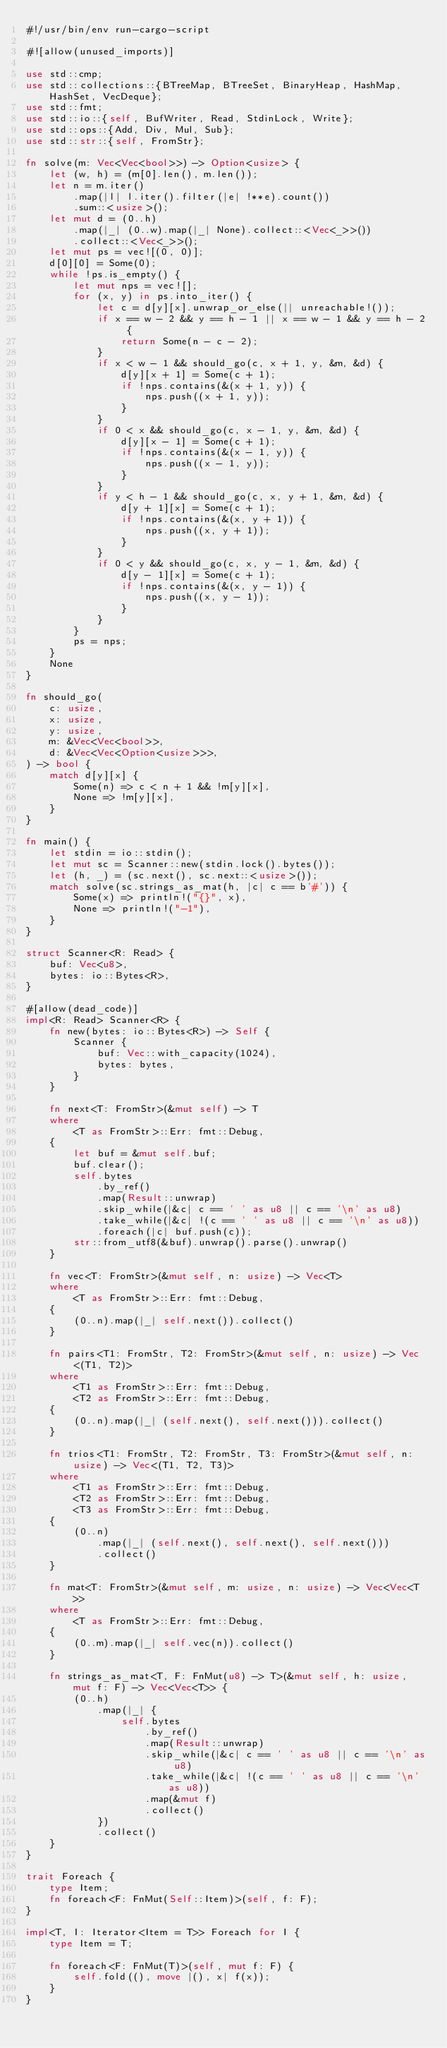<code> <loc_0><loc_0><loc_500><loc_500><_Rust_>#!/usr/bin/env run-cargo-script

#![allow(unused_imports)]

use std::cmp;
use std::collections::{BTreeMap, BTreeSet, BinaryHeap, HashMap, HashSet, VecDeque};
use std::fmt;
use std::io::{self, BufWriter, Read, StdinLock, Write};
use std::ops::{Add, Div, Mul, Sub};
use std::str::{self, FromStr};

fn solve(m: Vec<Vec<bool>>) -> Option<usize> {
    let (w, h) = (m[0].len(), m.len());
    let n = m.iter()
        .map(|l| l.iter().filter(|e| !**e).count())
        .sum::<usize>();
    let mut d = (0..h)
        .map(|_| (0..w).map(|_| None).collect::<Vec<_>>())
        .collect::<Vec<_>>();
    let mut ps = vec![(0, 0)];
    d[0][0] = Some(0);
    while !ps.is_empty() {
        let mut nps = vec![];
        for (x, y) in ps.into_iter() {
            let c = d[y][x].unwrap_or_else(|| unreachable!());
            if x == w - 2 && y == h - 1 || x == w - 1 && y == h - 2 {
                return Some(n - c - 2);
            }
            if x < w - 1 && should_go(c, x + 1, y, &m, &d) {
                d[y][x + 1] = Some(c + 1);
                if !nps.contains(&(x + 1, y)) {
                    nps.push((x + 1, y));
                }
            }
            if 0 < x && should_go(c, x - 1, y, &m, &d) {
                d[y][x - 1] = Some(c + 1);
                if !nps.contains(&(x - 1, y)) {
                    nps.push((x - 1, y));
                }
            }
            if y < h - 1 && should_go(c, x, y + 1, &m, &d) {
                d[y + 1][x] = Some(c + 1);
                if !nps.contains(&(x, y + 1)) {
                    nps.push((x, y + 1));
                }
            }
            if 0 < y && should_go(c, x, y - 1, &m, &d) {
                d[y - 1][x] = Some(c + 1);
                if !nps.contains(&(x, y - 1)) {
                    nps.push((x, y - 1));
                }
            }
        }
        ps = nps;
    }
    None
}

fn should_go(
    c: usize,
    x: usize,
    y: usize,
    m: &Vec<Vec<bool>>,
    d: &Vec<Vec<Option<usize>>>,
) -> bool {
    match d[y][x] {
        Some(n) => c < n + 1 && !m[y][x],
        None => !m[y][x],
    }
}

fn main() {
    let stdin = io::stdin();
    let mut sc = Scanner::new(stdin.lock().bytes());
    let (h, _) = (sc.next(), sc.next::<usize>());
    match solve(sc.strings_as_mat(h, |c| c == b'#')) {
        Some(x) => println!("{}", x),
        None => println!("-1"),
    }
}

struct Scanner<R: Read> {
    buf: Vec<u8>,
    bytes: io::Bytes<R>,
}

#[allow(dead_code)]
impl<R: Read> Scanner<R> {
    fn new(bytes: io::Bytes<R>) -> Self {
        Scanner {
            buf: Vec::with_capacity(1024),
            bytes: bytes,
        }
    }

    fn next<T: FromStr>(&mut self) -> T
    where
        <T as FromStr>::Err: fmt::Debug,
    {
        let buf = &mut self.buf;
        buf.clear();
        self.bytes
            .by_ref()
            .map(Result::unwrap)
            .skip_while(|&c| c == ' ' as u8 || c == '\n' as u8)
            .take_while(|&c| !(c == ' ' as u8 || c == '\n' as u8))
            .foreach(|c| buf.push(c));
        str::from_utf8(&buf).unwrap().parse().unwrap()
    }

    fn vec<T: FromStr>(&mut self, n: usize) -> Vec<T>
    where
        <T as FromStr>::Err: fmt::Debug,
    {
        (0..n).map(|_| self.next()).collect()
    }

    fn pairs<T1: FromStr, T2: FromStr>(&mut self, n: usize) -> Vec<(T1, T2)>
    where
        <T1 as FromStr>::Err: fmt::Debug,
        <T2 as FromStr>::Err: fmt::Debug,
    {
        (0..n).map(|_| (self.next(), self.next())).collect()
    }

    fn trios<T1: FromStr, T2: FromStr, T3: FromStr>(&mut self, n: usize) -> Vec<(T1, T2, T3)>
    where
        <T1 as FromStr>::Err: fmt::Debug,
        <T2 as FromStr>::Err: fmt::Debug,
        <T3 as FromStr>::Err: fmt::Debug,
    {
        (0..n)
            .map(|_| (self.next(), self.next(), self.next()))
            .collect()
    }

    fn mat<T: FromStr>(&mut self, m: usize, n: usize) -> Vec<Vec<T>>
    where
        <T as FromStr>::Err: fmt::Debug,
    {
        (0..m).map(|_| self.vec(n)).collect()
    }

    fn strings_as_mat<T, F: FnMut(u8) -> T>(&mut self, h: usize, mut f: F) -> Vec<Vec<T>> {
        (0..h)
            .map(|_| {
                self.bytes
                    .by_ref()
                    .map(Result::unwrap)
                    .skip_while(|&c| c == ' ' as u8 || c == '\n' as u8)
                    .take_while(|&c| !(c == ' ' as u8 || c == '\n' as u8))
                    .map(&mut f)
                    .collect()
            })
            .collect()
    }
}

trait Foreach {
    type Item;
    fn foreach<F: FnMut(Self::Item)>(self, f: F);
}

impl<T, I: Iterator<Item = T>> Foreach for I {
    type Item = T;

    fn foreach<F: FnMut(T)>(self, mut f: F) {
        self.fold((), move |(), x| f(x));
    }
}
</code> 